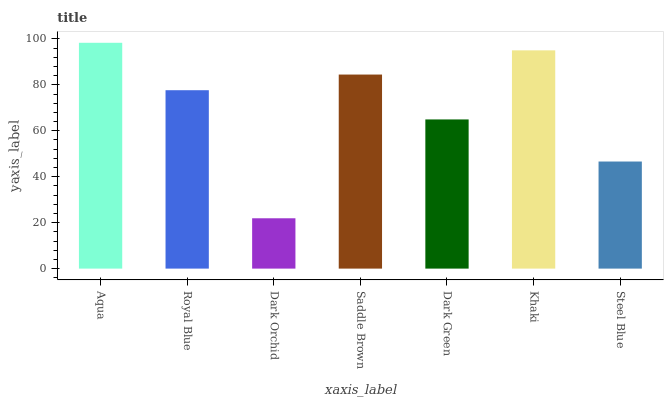Is Dark Orchid the minimum?
Answer yes or no. Yes. Is Aqua the maximum?
Answer yes or no. Yes. Is Royal Blue the minimum?
Answer yes or no. No. Is Royal Blue the maximum?
Answer yes or no. No. Is Aqua greater than Royal Blue?
Answer yes or no. Yes. Is Royal Blue less than Aqua?
Answer yes or no. Yes. Is Royal Blue greater than Aqua?
Answer yes or no. No. Is Aqua less than Royal Blue?
Answer yes or no. No. Is Royal Blue the high median?
Answer yes or no. Yes. Is Royal Blue the low median?
Answer yes or no. Yes. Is Saddle Brown the high median?
Answer yes or no. No. Is Steel Blue the low median?
Answer yes or no. No. 